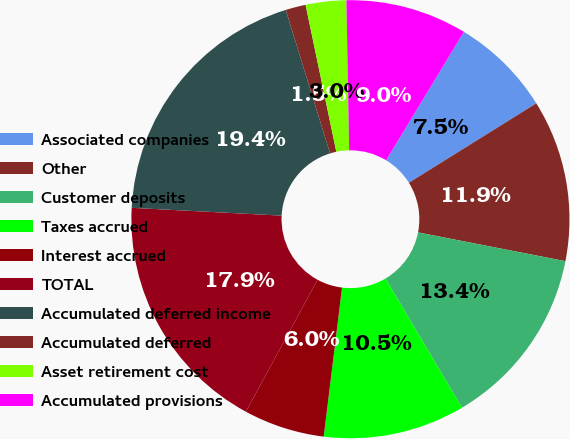Convert chart to OTSL. <chart><loc_0><loc_0><loc_500><loc_500><pie_chart><fcel>Associated companies<fcel>Other<fcel>Customer deposits<fcel>Taxes accrued<fcel>Interest accrued<fcel>TOTAL<fcel>Accumulated deferred income<fcel>Accumulated deferred<fcel>Asset retirement cost<fcel>Accumulated provisions<nl><fcel>7.46%<fcel>11.94%<fcel>13.43%<fcel>10.45%<fcel>5.97%<fcel>17.91%<fcel>19.4%<fcel>1.49%<fcel>2.99%<fcel>8.96%<nl></chart> 